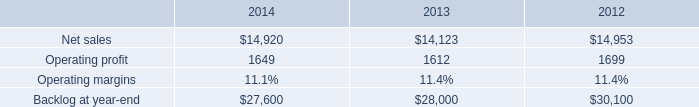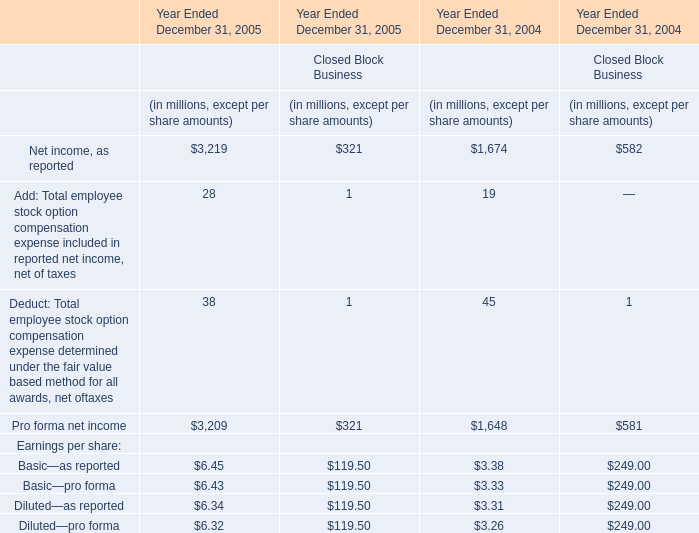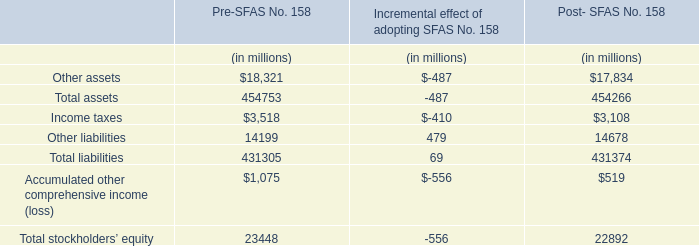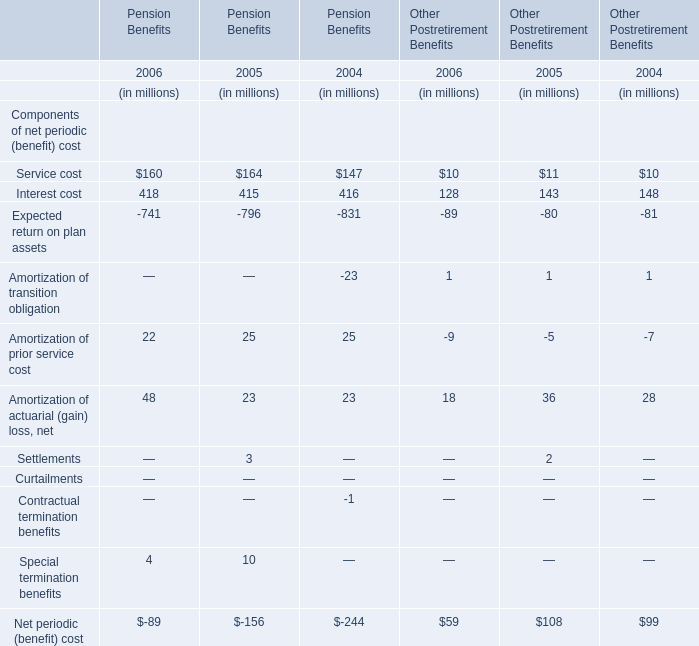What will Service cost for Pension Benefits be like in 2007 if it develops with the same increasing rate as current? (in million) 
Computations: (160 * (1 + ((160 - 164) / 164)))
Answer: 156.09756. 